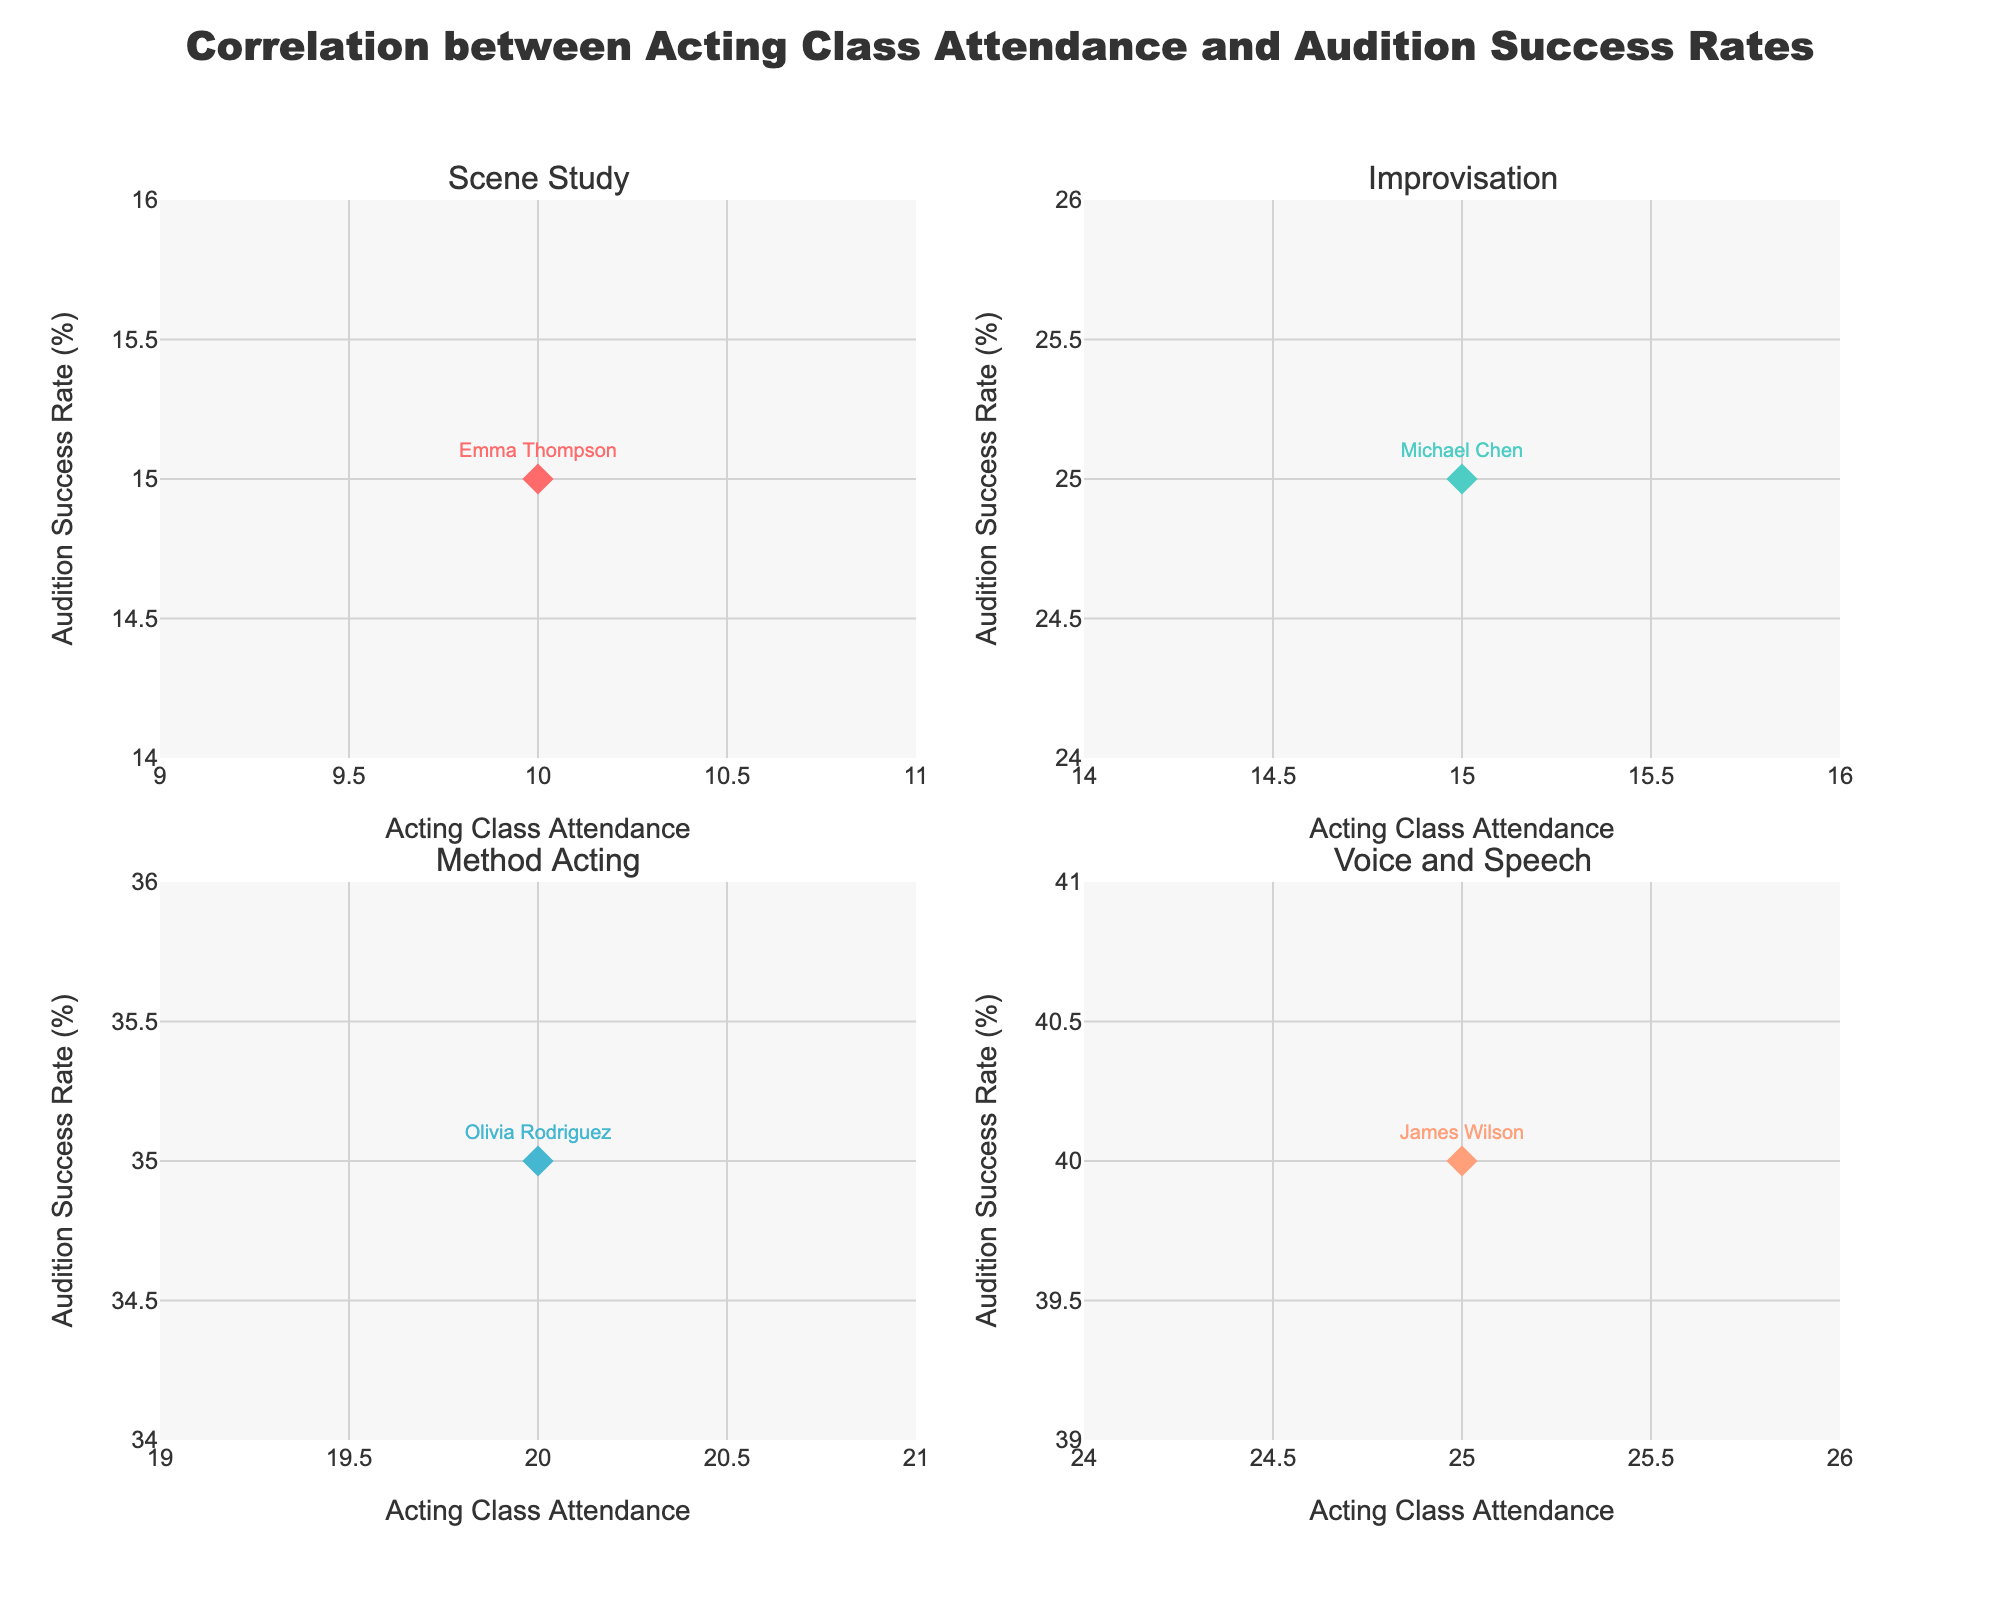What is the title of the scatterplot matrix? The title of a scatterplot matrix is usually prominently displayed at the top of the figure. It indicates the main topic or subject that the plot visualizes.
Answer: Relationship between Nutritional Intake, Body Composition, and Athletic Performance How many sports categories are represented in the scatterplot matrix? By examining the legend or the different color and symbol representations in the scatterplot matrix, you can count how many distinct sports categories are included.
Answer: 10 Which sport has the highest VO2 Max? Look at the scatterplot matrix and find the point with the maximum value on the VO2 Max axis. Identify the corresponding sport by its color or symbol.
Answer: Cycling Which sport has the lowest body fat percentage? Find the point with the minimum value on the Body Fat Percentage axis in the scatterplot matrix. Identify the corresponding sport by its color or symbol.
Answer: Gymnastics What is the relationship between Protein Intake and Sprint Time for Track_and_Field athletes? Locate the points representing Track_and_Field athletes and examine the scattergram that corresponds to Protein Intake versus Sprint Time. Identify any patterns, such as a trend or correlation.
Answer: Lower sprint time correlates with moderate protein intake around 105g Are there any outliers in the Body Fat Percentage vs. Vertical Jump plot? Locate the scattergram that plots Body Fat Percentage against Vertical Jump. Look for points that deviate significantly from the general cluster or trend.
Answer: Yes, Weightlifting appears as an outlier with high Body Fat and moderate Vertical Jump Which sport demonstrates the best vertical jump performance? Examine the scatterplot of Vertical Jump and identify the highest data points. Then, check which sport these points represent by their color or symbol.
Answer: Gymnastics Is there a visible correlation between VO2 Max and Protein Intake? Locate the scatterplot plotting VO2 Max against Protein Intake. Observe if there's a trend, such as an upward or downward slope, indicating positive or negative correlation.
Answer: No strong visible correlation How does the vertical jump performance of volleyball players compare to basketball players? Look at the points representing Volleyball and Basketball athletes in the scatterplot matrix's Vertical Jump axis and compare their positions.
Answer: Volleyball generally has higher vertical jump values than Basketball What is the average VO2 Max among all the sports categories? To find the average, sum the VO2 Max values for all sports categories and divide by the number of sports categories. For this dataset, sum = 55 + 52 + 65 + 58 + 70 + 54 + 60 + 52 + 48 + 75 = 589. Average = 589 / 10 = 58.9.
Answer: 58.9 